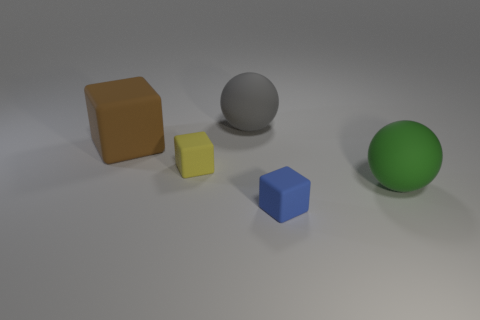How does the lighting affect the appearance of the objects? The lighting in the image casts soft shadows and highlights on the objects, emphasizing their shapes and giving the scene a three-dimensional quality. The gentle illumination also softens the textures, giving a calm and balanced visual experience. 